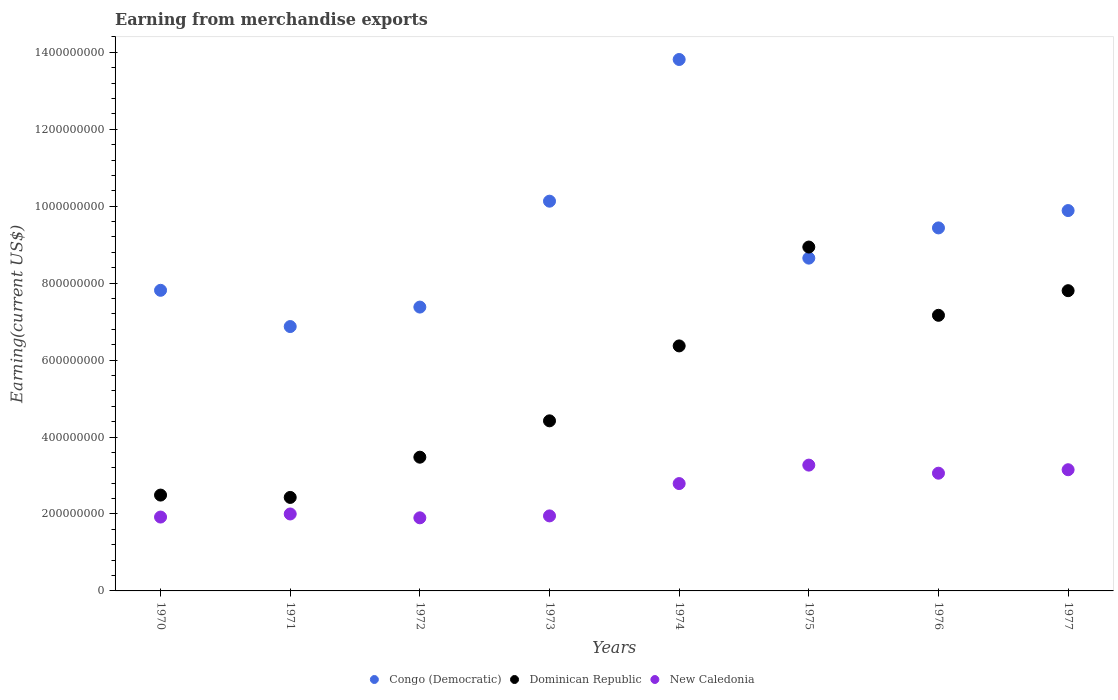Is the number of dotlines equal to the number of legend labels?
Provide a short and direct response. Yes. What is the amount earned from merchandise exports in Dominican Republic in 1977?
Your response must be concise. 7.80e+08. Across all years, what is the maximum amount earned from merchandise exports in New Caledonia?
Keep it short and to the point. 3.27e+08. Across all years, what is the minimum amount earned from merchandise exports in Congo (Democratic)?
Your answer should be compact. 6.87e+08. In which year was the amount earned from merchandise exports in Dominican Republic maximum?
Your response must be concise. 1975. What is the total amount earned from merchandise exports in New Caledonia in the graph?
Make the answer very short. 2.00e+09. What is the difference between the amount earned from merchandise exports in New Caledonia in 1973 and that in 1975?
Offer a terse response. -1.32e+08. What is the difference between the amount earned from merchandise exports in Congo (Democratic) in 1975 and the amount earned from merchandise exports in Dominican Republic in 1970?
Make the answer very short. 6.16e+08. What is the average amount earned from merchandise exports in Dominican Republic per year?
Keep it short and to the point. 5.39e+08. In the year 1972, what is the difference between the amount earned from merchandise exports in New Caledonia and amount earned from merchandise exports in Dominican Republic?
Provide a short and direct response. -1.58e+08. What is the ratio of the amount earned from merchandise exports in New Caledonia in 1971 to that in 1972?
Ensure brevity in your answer.  1.05. Is the amount earned from merchandise exports in New Caledonia in 1972 less than that in 1974?
Make the answer very short. Yes. Is the difference between the amount earned from merchandise exports in New Caledonia in 1970 and 1973 greater than the difference between the amount earned from merchandise exports in Dominican Republic in 1970 and 1973?
Keep it short and to the point. Yes. What is the difference between the highest and the second highest amount earned from merchandise exports in New Caledonia?
Offer a terse response. 1.20e+07. What is the difference between the highest and the lowest amount earned from merchandise exports in Congo (Democratic)?
Provide a succinct answer. 6.94e+08. Does the amount earned from merchandise exports in Dominican Republic monotonically increase over the years?
Your answer should be very brief. No. Is the amount earned from merchandise exports in Congo (Democratic) strictly greater than the amount earned from merchandise exports in Dominican Republic over the years?
Offer a terse response. No. Is the amount earned from merchandise exports in Dominican Republic strictly less than the amount earned from merchandise exports in Congo (Democratic) over the years?
Offer a terse response. No. How many years are there in the graph?
Make the answer very short. 8. Are the values on the major ticks of Y-axis written in scientific E-notation?
Your answer should be compact. No. Does the graph contain any zero values?
Provide a succinct answer. No. Where does the legend appear in the graph?
Your answer should be very brief. Bottom center. How are the legend labels stacked?
Make the answer very short. Horizontal. What is the title of the graph?
Ensure brevity in your answer.  Earning from merchandise exports. What is the label or title of the X-axis?
Your response must be concise. Years. What is the label or title of the Y-axis?
Provide a short and direct response. Earning(current US$). What is the Earning(current US$) of Congo (Democratic) in 1970?
Your response must be concise. 7.81e+08. What is the Earning(current US$) of Dominican Republic in 1970?
Keep it short and to the point. 2.49e+08. What is the Earning(current US$) of New Caledonia in 1970?
Your response must be concise. 1.92e+08. What is the Earning(current US$) of Congo (Democratic) in 1971?
Provide a succinct answer. 6.87e+08. What is the Earning(current US$) in Dominican Republic in 1971?
Your answer should be very brief. 2.43e+08. What is the Earning(current US$) in New Caledonia in 1971?
Provide a short and direct response. 2.00e+08. What is the Earning(current US$) of Congo (Democratic) in 1972?
Ensure brevity in your answer.  7.38e+08. What is the Earning(current US$) in Dominican Republic in 1972?
Provide a short and direct response. 3.48e+08. What is the Earning(current US$) of New Caledonia in 1972?
Offer a very short reply. 1.90e+08. What is the Earning(current US$) of Congo (Democratic) in 1973?
Give a very brief answer. 1.01e+09. What is the Earning(current US$) of Dominican Republic in 1973?
Your response must be concise. 4.42e+08. What is the Earning(current US$) of New Caledonia in 1973?
Ensure brevity in your answer.  1.95e+08. What is the Earning(current US$) of Congo (Democratic) in 1974?
Keep it short and to the point. 1.38e+09. What is the Earning(current US$) of Dominican Republic in 1974?
Ensure brevity in your answer.  6.37e+08. What is the Earning(current US$) in New Caledonia in 1974?
Make the answer very short. 2.79e+08. What is the Earning(current US$) in Congo (Democratic) in 1975?
Provide a short and direct response. 8.65e+08. What is the Earning(current US$) of Dominican Republic in 1975?
Offer a very short reply. 8.94e+08. What is the Earning(current US$) of New Caledonia in 1975?
Make the answer very short. 3.27e+08. What is the Earning(current US$) in Congo (Democratic) in 1976?
Provide a succinct answer. 9.44e+08. What is the Earning(current US$) in Dominican Republic in 1976?
Your answer should be very brief. 7.16e+08. What is the Earning(current US$) in New Caledonia in 1976?
Give a very brief answer. 3.06e+08. What is the Earning(current US$) of Congo (Democratic) in 1977?
Your answer should be very brief. 9.89e+08. What is the Earning(current US$) of Dominican Republic in 1977?
Provide a succinct answer. 7.80e+08. What is the Earning(current US$) in New Caledonia in 1977?
Make the answer very short. 3.15e+08. Across all years, what is the maximum Earning(current US$) in Congo (Democratic)?
Your answer should be very brief. 1.38e+09. Across all years, what is the maximum Earning(current US$) of Dominican Republic?
Offer a very short reply. 8.94e+08. Across all years, what is the maximum Earning(current US$) in New Caledonia?
Offer a very short reply. 3.27e+08. Across all years, what is the minimum Earning(current US$) of Congo (Democratic)?
Your answer should be compact. 6.87e+08. Across all years, what is the minimum Earning(current US$) of Dominican Republic?
Make the answer very short. 2.43e+08. Across all years, what is the minimum Earning(current US$) of New Caledonia?
Ensure brevity in your answer.  1.90e+08. What is the total Earning(current US$) in Congo (Democratic) in the graph?
Provide a succinct answer. 7.40e+09. What is the total Earning(current US$) of Dominican Republic in the graph?
Keep it short and to the point. 4.31e+09. What is the total Earning(current US$) in New Caledonia in the graph?
Give a very brief answer. 2.00e+09. What is the difference between the Earning(current US$) of Congo (Democratic) in 1970 and that in 1971?
Your answer should be compact. 9.42e+07. What is the difference between the Earning(current US$) of Dominican Republic in 1970 and that in 1971?
Offer a terse response. 6.07e+06. What is the difference between the Earning(current US$) in New Caledonia in 1970 and that in 1971?
Your answer should be very brief. -8.00e+06. What is the difference between the Earning(current US$) of Congo (Democratic) in 1970 and that in 1972?
Provide a succinct answer. 4.36e+07. What is the difference between the Earning(current US$) of Dominican Republic in 1970 and that in 1972?
Offer a very short reply. -9.85e+07. What is the difference between the Earning(current US$) of Congo (Democratic) in 1970 and that in 1973?
Your answer should be very brief. -2.32e+08. What is the difference between the Earning(current US$) in Dominican Republic in 1970 and that in 1973?
Your answer should be compact. -1.93e+08. What is the difference between the Earning(current US$) of New Caledonia in 1970 and that in 1973?
Ensure brevity in your answer.  -3.00e+06. What is the difference between the Earning(current US$) in Congo (Democratic) in 1970 and that in 1974?
Make the answer very short. -6.00e+08. What is the difference between the Earning(current US$) in Dominican Republic in 1970 and that in 1974?
Offer a terse response. -3.88e+08. What is the difference between the Earning(current US$) in New Caledonia in 1970 and that in 1974?
Your answer should be very brief. -8.70e+07. What is the difference between the Earning(current US$) of Congo (Democratic) in 1970 and that in 1975?
Give a very brief answer. -8.36e+07. What is the difference between the Earning(current US$) of Dominican Republic in 1970 and that in 1975?
Offer a terse response. -6.45e+08. What is the difference between the Earning(current US$) in New Caledonia in 1970 and that in 1975?
Give a very brief answer. -1.35e+08. What is the difference between the Earning(current US$) of Congo (Democratic) in 1970 and that in 1976?
Your response must be concise. -1.62e+08. What is the difference between the Earning(current US$) of Dominican Republic in 1970 and that in 1976?
Keep it short and to the point. -4.67e+08. What is the difference between the Earning(current US$) of New Caledonia in 1970 and that in 1976?
Your answer should be very brief. -1.14e+08. What is the difference between the Earning(current US$) in Congo (Democratic) in 1970 and that in 1977?
Give a very brief answer. -2.07e+08. What is the difference between the Earning(current US$) in Dominican Republic in 1970 and that in 1977?
Make the answer very short. -5.31e+08. What is the difference between the Earning(current US$) in New Caledonia in 1970 and that in 1977?
Keep it short and to the point. -1.23e+08. What is the difference between the Earning(current US$) in Congo (Democratic) in 1971 and that in 1972?
Your response must be concise. -5.06e+07. What is the difference between the Earning(current US$) of Dominican Republic in 1971 and that in 1972?
Give a very brief answer. -1.05e+08. What is the difference between the Earning(current US$) of New Caledonia in 1971 and that in 1972?
Ensure brevity in your answer.  1.00e+07. What is the difference between the Earning(current US$) in Congo (Democratic) in 1971 and that in 1973?
Your response must be concise. -3.26e+08. What is the difference between the Earning(current US$) in Dominican Republic in 1971 and that in 1973?
Your response must be concise. -1.99e+08. What is the difference between the Earning(current US$) of New Caledonia in 1971 and that in 1973?
Your answer should be very brief. 5.00e+06. What is the difference between the Earning(current US$) of Congo (Democratic) in 1971 and that in 1974?
Keep it short and to the point. -6.94e+08. What is the difference between the Earning(current US$) in Dominican Republic in 1971 and that in 1974?
Ensure brevity in your answer.  -3.94e+08. What is the difference between the Earning(current US$) of New Caledonia in 1971 and that in 1974?
Your answer should be compact. -7.90e+07. What is the difference between the Earning(current US$) in Congo (Democratic) in 1971 and that in 1975?
Give a very brief answer. -1.78e+08. What is the difference between the Earning(current US$) of Dominican Republic in 1971 and that in 1975?
Offer a terse response. -6.51e+08. What is the difference between the Earning(current US$) in New Caledonia in 1971 and that in 1975?
Offer a very short reply. -1.27e+08. What is the difference between the Earning(current US$) of Congo (Democratic) in 1971 and that in 1976?
Your answer should be compact. -2.56e+08. What is the difference between the Earning(current US$) in Dominican Republic in 1971 and that in 1976?
Your answer should be compact. -4.73e+08. What is the difference between the Earning(current US$) in New Caledonia in 1971 and that in 1976?
Your answer should be very brief. -1.06e+08. What is the difference between the Earning(current US$) in Congo (Democratic) in 1971 and that in 1977?
Offer a terse response. -3.01e+08. What is the difference between the Earning(current US$) in Dominican Republic in 1971 and that in 1977?
Make the answer very short. -5.37e+08. What is the difference between the Earning(current US$) in New Caledonia in 1971 and that in 1977?
Your response must be concise. -1.15e+08. What is the difference between the Earning(current US$) in Congo (Democratic) in 1972 and that in 1973?
Keep it short and to the point. -2.75e+08. What is the difference between the Earning(current US$) of Dominican Republic in 1972 and that in 1973?
Your answer should be very brief. -9.45e+07. What is the difference between the Earning(current US$) of New Caledonia in 1972 and that in 1973?
Keep it short and to the point. -5.00e+06. What is the difference between the Earning(current US$) in Congo (Democratic) in 1972 and that in 1974?
Offer a terse response. -6.44e+08. What is the difference between the Earning(current US$) in Dominican Republic in 1972 and that in 1974?
Provide a short and direct response. -2.89e+08. What is the difference between the Earning(current US$) of New Caledonia in 1972 and that in 1974?
Your response must be concise. -8.90e+07. What is the difference between the Earning(current US$) in Congo (Democratic) in 1972 and that in 1975?
Keep it short and to the point. -1.27e+08. What is the difference between the Earning(current US$) in Dominican Republic in 1972 and that in 1975?
Give a very brief answer. -5.46e+08. What is the difference between the Earning(current US$) in New Caledonia in 1972 and that in 1975?
Keep it short and to the point. -1.37e+08. What is the difference between the Earning(current US$) in Congo (Democratic) in 1972 and that in 1976?
Provide a succinct answer. -2.06e+08. What is the difference between the Earning(current US$) of Dominican Republic in 1972 and that in 1976?
Offer a very short reply. -3.69e+08. What is the difference between the Earning(current US$) of New Caledonia in 1972 and that in 1976?
Offer a terse response. -1.16e+08. What is the difference between the Earning(current US$) of Congo (Democratic) in 1972 and that in 1977?
Keep it short and to the point. -2.51e+08. What is the difference between the Earning(current US$) of Dominican Republic in 1972 and that in 1977?
Your answer should be compact. -4.33e+08. What is the difference between the Earning(current US$) of New Caledonia in 1972 and that in 1977?
Make the answer very short. -1.25e+08. What is the difference between the Earning(current US$) of Congo (Democratic) in 1973 and that in 1974?
Ensure brevity in your answer.  -3.68e+08. What is the difference between the Earning(current US$) of Dominican Republic in 1973 and that in 1974?
Offer a terse response. -1.95e+08. What is the difference between the Earning(current US$) in New Caledonia in 1973 and that in 1974?
Give a very brief answer. -8.40e+07. What is the difference between the Earning(current US$) of Congo (Democratic) in 1973 and that in 1975?
Your answer should be very brief. 1.48e+08. What is the difference between the Earning(current US$) in Dominican Republic in 1973 and that in 1975?
Provide a short and direct response. -4.52e+08. What is the difference between the Earning(current US$) in New Caledonia in 1973 and that in 1975?
Provide a succinct answer. -1.32e+08. What is the difference between the Earning(current US$) of Congo (Democratic) in 1973 and that in 1976?
Your answer should be very brief. 6.95e+07. What is the difference between the Earning(current US$) of Dominican Republic in 1973 and that in 1976?
Make the answer very short. -2.74e+08. What is the difference between the Earning(current US$) of New Caledonia in 1973 and that in 1976?
Ensure brevity in your answer.  -1.11e+08. What is the difference between the Earning(current US$) in Congo (Democratic) in 1973 and that in 1977?
Keep it short and to the point. 2.44e+07. What is the difference between the Earning(current US$) in Dominican Republic in 1973 and that in 1977?
Provide a succinct answer. -3.38e+08. What is the difference between the Earning(current US$) in New Caledonia in 1973 and that in 1977?
Offer a terse response. -1.20e+08. What is the difference between the Earning(current US$) of Congo (Democratic) in 1974 and that in 1975?
Provide a succinct answer. 5.16e+08. What is the difference between the Earning(current US$) of Dominican Republic in 1974 and that in 1975?
Make the answer very short. -2.57e+08. What is the difference between the Earning(current US$) in New Caledonia in 1974 and that in 1975?
Your answer should be very brief. -4.80e+07. What is the difference between the Earning(current US$) in Congo (Democratic) in 1974 and that in 1976?
Offer a very short reply. 4.38e+08. What is the difference between the Earning(current US$) in Dominican Republic in 1974 and that in 1976?
Give a very brief answer. -7.95e+07. What is the difference between the Earning(current US$) of New Caledonia in 1974 and that in 1976?
Your answer should be compact. -2.70e+07. What is the difference between the Earning(current US$) in Congo (Democratic) in 1974 and that in 1977?
Provide a succinct answer. 3.93e+08. What is the difference between the Earning(current US$) of Dominican Republic in 1974 and that in 1977?
Offer a very short reply. -1.44e+08. What is the difference between the Earning(current US$) of New Caledonia in 1974 and that in 1977?
Keep it short and to the point. -3.60e+07. What is the difference between the Earning(current US$) in Congo (Democratic) in 1975 and that in 1976?
Your answer should be compact. -7.86e+07. What is the difference between the Earning(current US$) in Dominican Republic in 1975 and that in 1976?
Provide a succinct answer. 1.77e+08. What is the difference between the Earning(current US$) in New Caledonia in 1975 and that in 1976?
Offer a terse response. 2.10e+07. What is the difference between the Earning(current US$) of Congo (Democratic) in 1975 and that in 1977?
Ensure brevity in your answer.  -1.24e+08. What is the difference between the Earning(current US$) of Dominican Republic in 1975 and that in 1977?
Make the answer very short. 1.13e+08. What is the difference between the Earning(current US$) of Congo (Democratic) in 1976 and that in 1977?
Your response must be concise. -4.51e+07. What is the difference between the Earning(current US$) of Dominican Republic in 1976 and that in 1977?
Provide a short and direct response. -6.40e+07. What is the difference between the Earning(current US$) of New Caledonia in 1976 and that in 1977?
Provide a short and direct response. -9.00e+06. What is the difference between the Earning(current US$) of Congo (Democratic) in 1970 and the Earning(current US$) of Dominican Republic in 1971?
Offer a very short reply. 5.38e+08. What is the difference between the Earning(current US$) of Congo (Democratic) in 1970 and the Earning(current US$) of New Caledonia in 1971?
Offer a very short reply. 5.81e+08. What is the difference between the Earning(current US$) in Dominican Republic in 1970 and the Earning(current US$) in New Caledonia in 1971?
Make the answer very short. 4.91e+07. What is the difference between the Earning(current US$) of Congo (Democratic) in 1970 and the Earning(current US$) of Dominican Republic in 1972?
Give a very brief answer. 4.34e+08. What is the difference between the Earning(current US$) in Congo (Democratic) in 1970 and the Earning(current US$) in New Caledonia in 1972?
Provide a succinct answer. 5.91e+08. What is the difference between the Earning(current US$) of Dominican Republic in 1970 and the Earning(current US$) of New Caledonia in 1972?
Give a very brief answer. 5.91e+07. What is the difference between the Earning(current US$) of Congo (Democratic) in 1970 and the Earning(current US$) of Dominican Republic in 1973?
Provide a short and direct response. 3.39e+08. What is the difference between the Earning(current US$) of Congo (Democratic) in 1970 and the Earning(current US$) of New Caledonia in 1973?
Make the answer very short. 5.86e+08. What is the difference between the Earning(current US$) in Dominican Republic in 1970 and the Earning(current US$) in New Caledonia in 1973?
Keep it short and to the point. 5.41e+07. What is the difference between the Earning(current US$) in Congo (Democratic) in 1970 and the Earning(current US$) in Dominican Republic in 1974?
Make the answer very short. 1.45e+08. What is the difference between the Earning(current US$) in Congo (Democratic) in 1970 and the Earning(current US$) in New Caledonia in 1974?
Offer a very short reply. 5.02e+08. What is the difference between the Earning(current US$) of Dominican Republic in 1970 and the Earning(current US$) of New Caledonia in 1974?
Give a very brief answer. -2.99e+07. What is the difference between the Earning(current US$) in Congo (Democratic) in 1970 and the Earning(current US$) in Dominican Republic in 1975?
Ensure brevity in your answer.  -1.12e+08. What is the difference between the Earning(current US$) of Congo (Democratic) in 1970 and the Earning(current US$) of New Caledonia in 1975?
Your response must be concise. 4.54e+08. What is the difference between the Earning(current US$) of Dominican Republic in 1970 and the Earning(current US$) of New Caledonia in 1975?
Make the answer very short. -7.79e+07. What is the difference between the Earning(current US$) of Congo (Democratic) in 1970 and the Earning(current US$) of Dominican Republic in 1976?
Your answer should be compact. 6.50e+07. What is the difference between the Earning(current US$) of Congo (Democratic) in 1970 and the Earning(current US$) of New Caledonia in 1976?
Ensure brevity in your answer.  4.75e+08. What is the difference between the Earning(current US$) of Dominican Republic in 1970 and the Earning(current US$) of New Caledonia in 1976?
Your answer should be very brief. -5.69e+07. What is the difference between the Earning(current US$) in Congo (Democratic) in 1970 and the Earning(current US$) in Dominican Republic in 1977?
Provide a succinct answer. 9.97e+05. What is the difference between the Earning(current US$) in Congo (Democratic) in 1970 and the Earning(current US$) in New Caledonia in 1977?
Your answer should be very brief. 4.66e+08. What is the difference between the Earning(current US$) in Dominican Republic in 1970 and the Earning(current US$) in New Caledonia in 1977?
Provide a short and direct response. -6.59e+07. What is the difference between the Earning(current US$) in Congo (Democratic) in 1971 and the Earning(current US$) in Dominican Republic in 1972?
Make the answer very short. 3.40e+08. What is the difference between the Earning(current US$) in Congo (Democratic) in 1971 and the Earning(current US$) in New Caledonia in 1972?
Offer a terse response. 4.97e+08. What is the difference between the Earning(current US$) of Dominican Republic in 1971 and the Earning(current US$) of New Caledonia in 1972?
Ensure brevity in your answer.  5.30e+07. What is the difference between the Earning(current US$) in Congo (Democratic) in 1971 and the Earning(current US$) in Dominican Republic in 1973?
Ensure brevity in your answer.  2.45e+08. What is the difference between the Earning(current US$) of Congo (Democratic) in 1971 and the Earning(current US$) of New Caledonia in 1973?
Make the answer very short. 4.92e+08. What is the difference between the Earning(current US$) of Dominican Republic in 1971 and the Earning(current US$) of New Caledonia in 1973?
Keep it short and to the point. 4.80e+07. What is the difference between the Earning(current US$) of Congo (Democratic) in 1971 and the Earning(current US$) of Dominican Republic in 1974?
Offer a very short reply. 5.03e+07. What is the difference between the Earning(current US$) of Congo (Democratic) in 1971 and the Earning(current US$) of New Caledonia in 1974?
Provide a succinct answer. 4.08e+08. What is the difference between the Earning(current US$) of Dominican Republic in 1971 and the Earning(current US$) of New Caledonia in 1974?
Your response must be concise. -3.60e+07. What is the difference between the Earning(current US$) of Congo (Democratic) in 1971 and the Earning(current US$) of Dominican Republic in 1975?
Provide a succinct answer. -2.07e+08. What is the difference between the Earning(current US$) in Congo (Democratic) in 1971 and the Earning(current US$) in New Caledonia in 1975?
Your answer should be compact. 3.60e+08. What is the difference between the Earning(current US$) in Dominican Republic in 1971 and the Earning(current US$) in New Caledonia in 1975?
Provide a succinct answer. -8.40e+07. What is the difference between the Earning(current US$) in Congo (Democratic) in 1971 and the Earning(current US$) in Dominican Republic in 1976?
Make the answer very short. -2.92e+07. What is the difference between the Earning(current US$) in Congo (Democratic) in 1971 and the Earning(current US$) in New Caledonia in 1976?
Ensure brevity in your answer.  3.81e+08. What is the difference between the Earning(current US$) of Dominican Republic in 1971 and the Earning(current US$) of New Caledonia in 1976?
Your answer should be compact. -6.30e+07. What is the difference between the Earning(current US$) of Congo (Democratic) in 1971 and the Earning(current US$) of Dominican Republic in 1977?
Make the answer very short. -9.32e+07. What is the difference between the Earning(current US$) in Congo (Democratic) in 1971 and the Earning(current US$) in New Caledonia in 1977?
Make the answer very short. 3.72e+08. What is the difference between the Earning(current US$) in Dominican Republic in 1971 and the Earning(current US$) in New Caledonia in 1977?
Ensure brevity in your answer.  -7.20e+07. What is the difference between the Earning(current US$) of Congo (Democratic) in 1972 and the Earning(current US$) of Dominican Republic in 1973?
Your answer should be compact. 2.96e+08. What is the difference between the Earning(current US$) of Congo (Democratic) in 1972 and the Earning(current US$) of New Caledonia in 1973?
Provide a short and direct response. 5.43e+08. What is the difference between the Earning(current US$) of Dominican Republic in 1972 and the Earning(current US$) of New Caledonia in 1973?
Make the answer very short. 1.53e+08. What is the difference between the Earning(current US$) in Congo (Democratic) in 1972 and the Earning(current US$) in Dominican Republic in 1974?
Your answer should be very brief. 1.01e+08. What is the difference between the Earning(current US$) in Congo (Democratic) in 1972 and the Earning(current US$) in New Caledonia in 1974?
Provide a short and direct response. 4.59e+08. What is the difference between the Earning(current US$) in Dominican Republic in 1972 and the Earning(current US$) in New Caledonia in 1974?
Keep it short and to the point. 6.86e+07. What is the difference between the Earning(current US$) of Congo (Democratic) in 1972 and the Earning(current US$) of Dominican Republic in 1975?
Your response must be concise. -1.56e+08. What is the difference between the Earning(current US$) of Congo (Democratic) in 1972 and the Earning(current US$) of New Caledonia in 1975?
Offer a terse response. 4.11e+08. What is the difference between the Earning(current US$) of Dominican Republic in 1972 and the Earning(current US$) of New Caledonia in 1975?
Keep it short and to the point. 2.06e+07. What is the difference between the Earning(current US$) of Congo (Democratic) in 1972 and the Earning(current US$) of Dominican Republic in 1976?
Your answer should be compact. 2.14e+07. What is the difference between the Earning(current US$) in Congo (Democratic) in 1972 and the Earning(current US$) in New Caledonia in 1976?
Your response must be concise. 4.32e+08. What is the difference between the Earning(current US$) of Dominican Republic in 1972 and the Earning(current US$) of New Caledonia in 1976?
Offer a terse response. 4.16e+07. What is the difference between the Earning(current US$) of Congo (Democratic) in 1972 and the Earning(current US$) of Dominican Republic in 1977?
Provide a short and direct response. -4.26e+07. What is the difference between the Earning(current US$) in Congo (Democratic) in 1972 and the Earning(current US$) in New Caledonia in 1977?
Make the answer very short. 4.23e+08. What is the difference between the Earning(current US$) in Dominican Republic in 1972 and the Earning(current US$) in New Caledonia in 1977?
Your answer should be very brief. 3.26e+07. What is the difference between the Earning(current US$) in Congo (Democratic) in 1973 and the Earning(current US$) in Dominican Republic in 1974?
Offer a terse response. 3.76e+08. What is the difference between the Earning(current US$) in Congo (Democratic) in 1973 and the Earning(current US$) in New Caledonia in 1974?
Keep it short and to the point. 7.34e+08. What is the difference between the Earning(current US$) in Dominican Republic in 1973 and the Earning(current US$) in New Caledonia in 1974?
Offer a very short reply. 1.63e+08. What is the difference between the Earning(current US$) in Congo (Democratic) in 1973 and the Earning(current US$) in Dominican Republic in 1975?
Keep it short and to the point. 1.19e+08. What is the difference between the Earning(current US$) in Congo (Democratic) in 1973 and the Earning(current US$) in New Caledonia in 1975?
Give a very brief answer. 6.86e+08. What is the difference between the Earning(current US$) of Dominican Republic in 1973 and the Earning(current US$) of New Caledonia in 1975?
Make the answer very short. 1.15e+08. What is the difference between the Earning(current US$) of Congo (Democratic) in 1973 and the Earning(current US$) of Dominican Republic in 1976?
Make the answer very short. 2.97e+08. What is the difference between the Earning(current US$) in Congo (Democratic) in 1973 and the Earning(current US$) in New Caledonia in 1976?
Keep it short and to the point. 7.07e+08. What is the difference between the Earning(current US$) of Dominican Republic in 1973 and the Earning(current US$) of New Caledonia in 1976?
Ensure brevity in your answer.  1.36e+08. What is the difference between the Earning(current US$) in Congo (Democratic) in 1973 and the Earning(current US$) in Dominican Republic in 1977?
Keep it short and to the point. 2.33e+08. What is the difference between the Earning(current US$) in Congo (Democratic) in 1973 and the Earning(current US$) in New Caledonia in 1977?
Give a very brief answer. 6.98e+08. What is the difference between the Earning(current US$) of Dominican Republic in 1973 and the Earning(current US$) of New Caledonia in 1977?
Make the answer very short. 1.27e+08. What is the difference between the Earning(current US$) in Congo (Democratic) in 1974 and the Earning(current US$) in Dominican Republic in 1975?
Your answer should be compact. 4.87e+08. What is the difference between the Earning(current US$) in Congo (Democratic) in 1974 and the Earning(current US$) in New Caledonia in 1975?
Make the answer very short. 1.05e+09. What is the difference between the Earning(current US$) of Dominican Republic in 1974 and the Earning(current US$) of New Caledonia in 1975?
Keep it short and to the point. 3.10e+08. What is the difference between the Earning(current US$) in Congo (Democratic) in 1974 and the Earning(current US$) in Dominican Republic in 1976?
Ensure brevity in your answer.  6.65e+08. What is the difference between the Earning(current US$) of Congo (Democratic) in 1974 and the Earning(current US$) of New Caledonia in 1976?
Ensure brevity in your answer.  1.08e+09. What is the difference between the Earning(current US$) in Dominican Republic in 1974 and the Earning(current US$) in New Caledonia in 1976?
Ensure brevity in your answer.  3.31e+08. What is the difference between the Earning(current US$) in Congo (Democratic) in 1974 and the Earning(current US$) in Dominican Republic in 1977?
Provide a succinct answer. 6.01e+08. What is the difference between the Earning(current US$) of Congo (Democratic) in 1974 and the Earning(current US$) of New Caledonia in 1977?
Provide a short and direct response. 1.07e+09. What is the difference between the Earning(current US$) of Dominican Republic in 1974 and the Earning(current US$) of New Caledonia in 1977?
Your answer should be very brief. 3.22e+08. What is the difference between the Earning(current US$) in Congo (Democratic) in 1975 and the Earning(current US$) in Dominican Republic in 1976?
Your answer should be compact. 1.49e+08. What is the difference between the Earning(current US$) of Congo (Democratic) in 1975 and the Earning(current US$) of New Caledonia in 1976?
Offer a very short reply. 5.59e+08. What is the difference between the Earning(current US$) in Dominican Republic in 1975 and the Earning(current US$) in New Caledonia in 1976?
Your response must be concise. 5.88e+08. What is the difference between the Earning(current US$) of Congo (Democratic) in 1975 and the Earning(current US$) of Dominican Republic in 1977?
Ensure brevity in your answer.  8.46e+07. What is the difference between the Earning(current US$) of Congo (Democratic) in 1975 and the Earning(current US$) of New Caledonia in 1977?
Give a very brief answer. 5.50e+08. What is the difference between the Earning(current US$) of Dominican Republic in 1975 and the Earning(current US$) of New Caledonia in 1977?
Offer a very short reply. 5.79e+08. What is the difference between the Earning(current US$) in Congo (Democratic) in 1976 and the Earning(current US$) in Dominican Republic in 1977?
Make the answer very short. 1.63e+08. What is the difference between the Earning(current US$) in Congo (Democratic) in 1976 and the Earning(current US$) in New Caledonia in 1977?
Give a very brief answer. 6.29e+08. What is the difference between the Earning(current US$) in Dominican Republic in 1976 and the Earning(current US$) in New Caledonia in 1977?
Give a very brief answer. 4.01e+08. What is the average Earning(current US$) in Congo (Democratic) per year?
Ensure brevity in your answer.  9.25e+08. What is the average Earning(current US$) in Dominican Republic per year?
Keep it short and to the point. 5.39e+08. What is the average Earning(current US$) in New Caledonia per year?
Offer a terse response. 2.50e+08. In the year 1970, what is the difference between the Earning(current US$) in Congo (Democratic) and Earning(current US$) in Dominican Republic?
Make the answer very short. 5.32e+08. In the year 1970, what is the difference between the Earning(current US$) of Congo (Democratic) and Earning(current US$) of New Caledonia?
Provide a short and direct response. 5.89e+08. In the year 1970, what is the difference between the Earning(current US$) in Dominican Republic and Earning(current US$) in New Caledonia?
Ensure brevity in your answer.  5.71e+07. In the year 1971, what is the difference between the Earning(current US$) in Congo (Democratic) and Earning(current US$) in Dominican Republic?
Provide a short and direct response. 4.44e+08. In the year 1971, what is the difference between the Earning(current US$) of Congo (Democratic) and Earning(current US$) of New Caledonia?
Your answer should be very brief. 4.87e+08. In the year 1971, what is the difference between the Earning(current US$) in Dominican Republic and Earning(current US$) in New Caledonia?
Your answer should be very brief. 4.30e+07. In the year 1972, what is the difference between the Earning(current US$) in Congo (Democratic) and Earning(current US$) in Dominican Republic?
Ensure brevity in your answer.  3.90e+08. In the year 1972, what is the difference between the Earning(current US$) of Congo (Democratic) and Earning(current US$) of New Caledonia?
Your answer should be very brief. 5.48e+08. In the year 1972, what is the difference between the Earning(current US$) of Dominican Republic and Earning(current US$) of New Caledonia?
Give a very brief answer. 1.58e+08. In the year 1973, what is the difference between the Earning(current US$) in Congo (Democratic) and Earning(current US$) in Dominican Republic?
Ensure brevity in your answer.  5.71e+08. In the year 1973, what is the difference between the Earning(current US$) of Congo (Democratic) and Earning(current US$) of New Caledonia?
Offer a terse response. 8.18e+08. In the year 1973, what is the difference between the Earning(current US$) of Dominican Republic and Earning(current US$) of New Caledonia?
Provide a short and direct response. 2.47e+08. In the year 1974, what is the difference between the Earning(current US$) in Congo (Democratic) and Earning(current US$) in Dominican Republic?
Provide a short and direct response. 7.44e+08. In the year 1974, what is the difference between the Earning(current US$) in Congo (Democratic) and Earning(current US$) in New Caledonia?
Provide a succinct answer. 1.10e+09. In the year 1974, what is the difference between the Earning(current US$) of Dominican Republic and Earning(current US$) of New Caledonia?
Offer a terse response. 3.58e+08. In the year 1975, what is the difference between the Earning(current US$) of Congo (Democratic) and Earning(current US$) of Dominican Republic?
Provide a succinct answer. -2.88e+07. In the year 1975, what is the difference between the Earning(current US$) in Congo (Democratic) and Earning(current US$) in New Caledonia?
Keep it short and to the point. 5.38e+08. In the year 1975, what is the difference between the Earning(current US$) of Dominican Republic and Earning(current US$) of New Caledonia?
Your answer should be very brief. 5.67e+08. In the year 1976, what is the difference between the Earning(current US$) in Congo (Democratic) and Earning(current US$) in Dominican Republic?
Provide a short and direct response. 2.27e+08. In the year 1976, what is the difference between the Earning(current US$) in Congo (Democratic) and Earning(current US$) in New Caledonia?
Provide a short and direct response. 6.38e+08. In the year 1976, what is the difference between the Earning(current US$) in Dominican Republic and Earning(current US$) in New Caledonia?
Your answer should be very brief. 4.10e+08. In the year 1977, what is the difference between the Earning(current US$) in Congo (Democratic) and Earning(current US$) in Dominican Republic?
Offer a terse response. 2.08e+08. In the year 1977, what is the difference between the Earning(current US$) of Congo (Democratic) and Earning(current US$) of New Caledonia?
Ensure brevity in your answer.  6.74e+08. In the year 1977, what is the difference between the Earning(current US$) in Dominican Republic and Earning(current US$) in New Caledonia?
Provide a succinct answer. 4.65e+08. What is the ratio of the Earning(current US$) of Congo (Democratic) in 1970 to that in 1971?
Give a very brief answer. 1.14. What is the ratio of the Earning(current US$) in Dominican Republic in 1970 to that in 1971?
Give a very brief answer. 1.02. What is the ratio of the Earning(current US$) in Congo (Democratic) in 1970 to that in 1972?
Your answer should be very brief. 1.06. What is the ratio of the Earning(current US$) of Dominican Republic in 1970 to that in 1972?
Offer a very short reply. 0.72. What is the ratio of the Earning(current US$) in New Caledonia in 1970 to that in 1972?
Ensure brevity in your answer.  1.01. What is the ratio of the Earning(current US$) of Congo (Democratic) in 1970 to that in 1973?
Provide a succinct answer. 0.77. What is the ratio of the Earning(current US$) of Dominican Republic in 1970 to that in 1973?
Offer a very short reply. 0.56. What is the ratio of the Earning(current US$) in New Caledonia in 1970 to that in 1973?
Make the answer very short. 0.98. What is the ratio of the Earning(current US$) in Congo (Democratic) in 1970 to that in 1974?
Give a very brief answer. 0.57. What is the ratio of the Earning(current US$) of Dominican Republic in 1970 to that in 1974?
Give a very brief answer. 0.39. What is the ratio of the Earning(current US$) of New Caledonia in 1970 to that in 1974?
Keep it short and to the point. 0.69. What is the ratio of the Earning(current US$) of Congo (Democratic) in 1970 to that in 1975?
Give a very brief answer. 0.9. What is the ratio of the Earning(current US$) of Dominican Republic in 1970 to that in 1975?
Your response must be concise. 0.28. What is the ratio of the Earning(current US$) in New Caledonia in 1970 to that in 1975?
Ensure brevity in your answer.  0.59. What is the ratio of the Earning(current US$) of Congo (Democratic) in 1970 to that in 1976?
Offer a terse response. 0.83. What is the ratio of the Earning(current US$) of Dominican Republic in 1970 to that in 1976?
Your answer should be very brief. 0.35. What is the ratio of the Earning(current US$) of New Caledonia in 1970 to that in 1976?
Your response must be concise. 0.63. What is the ratio of the Earning(current US$) of Congo (Democratic) in 1970 to that in 1977?
Your response must be concise. 0.79. What is the ratio of the Earning(current US$) in Dominican Republic in 1970 to that in 1977?
Provide a succinct answer. 0.32. What is the ratio of the Earning(current US$) of New Caledonia in 1970 to that in 1977?
Offer a terse response. 0.61. What is the ratio of the Earning(current US$) in Congo (Democratic) in 1971 to that in 1972?
Offer a very short reply. 0.93. What is the ratio of the Earning(current US$) in Dominican Republic in 1971 to that in 1972?
Your response must be concise. 0.7. What is the ratio of the Earning(current US$) in New Caledonia in 1971 to that in 1972?
Your answer should be very brief. 1.05. What is the ratio of the Earning(current US$) of Congo (Democratic) in 1971 to that in 1973?
Give a very brief answer. 0.68. What is the ratio of the Earning(current US$) of Dominican Republic in 1971 to that in 1973?
Your answer should be very brief. 0.55. What is the ratio of the Earning(current US$) of New Caledonia in 1971 to that in 1973?
Keep it short and to the point. 1.03. What is the ratio of the Earning(current US$) of Congo (Democratic) in 1971 to that in 1974?
Offer a very short reply. 0.5. What is the ratio of the Earning(current US$) of Dominican Republic in 1971 to that in 1974?
Make the answer very short. 0.38. What is the ratio of the Earning(current US$) of New Caledonia in 1971 to that in 1974?
Your answer should be compact. 0.72. What is the ratio of the Earning(current US$) in Congo (Democratic) in 1971 to that in 1975?
Ensure brevity in your answer.  0.79. What is the ratio of the Earning(current US$) in Dominican Republic in 1971 to that in 1975?
Offer a very short reply. 0.27. What is the ratio of the Earning(current US$) in New Caledonia in 1971 to that in 1975?
Keep it short and to the point. 0.61. What is the ratio of the Earning(current US$) in Congo (Democratic) in 1971 to that in 1976?
Keep it short and to the point. 0.73. What is the ratio of the Earning(current US$) in Dominican Republic in 1971 to that in 1976?
Keep it short and to the point. 0.34. What is the ratio of the Earning(current US$) of New Caledonia in 1971 to that in 1976?
Your answer should be very brief. 0.65. What is the ratio of the Earning(current US$) of Congo (Democratic) in 1971 to that in 1977?
Provide a short and direct response. 0.7. What is the ratio of the Earning(current US$) of Dominican Republic in 1971 to that in 1977?
Ensure brevity in your answer.  0.31. What is the ratio of the Earning(current US$) in New Caledonia in 1971 to that in 1977?
Give a very brief answer. 0.63. What is the ratio of the Earning(current US$) of Congo (Democratic) in 1972 to that in 1973?
Give a very brief answer. 0.73. What is the ratio of the Earning(current US$) in Dominican Republic in 1972 to that in 1973?
Provide a succinct answer. 0.79. What is the ratio of the Earning(current US$) of New Caledonia in 1972 to that in 1973?
Your response must be concise. 0.97. What is the ratio of the Earning(current US$) in Congo (Democratic) in 1972 to that in 1974?
Provide a short and direct response. 0.53. What is the ratio of the Earning(current US$) of Dominican Republic in 1972 to that in 1974?
Give a very brief answer. 0.55. What is the ratio of the Earning(current US$) of New Caledonia in 1972 to that in 1974?
Keep it short and to the point. 0.68. What is the ratio of the Earning(current US$) of Congo (Democratic) in 1972 to that in 1975?
Make the answer very short. 0.85. What is the ratio of the Earning(current US$) in Dominican Republic in 1972 to that in 1975?
Your answer should be compact. 0.39. What is the ratio of the Earning(current US$) in New Caledonia in 1972 to that in 1975?
Provide a succinct answer. 0.58. What is the ratio of the Earning(current US$) in Congo (Democratic) in 1972 to that in 1976?
Make the answer very short. 0.78. What is the ratio of the Earning(current US$) of Dominican Republic in 1972 to that in 1976?
Ensure brevity in your answer.  0.49. What is the ratio of the Earning(current US$) in New Caledonia in 1972 to that in 1976?
Offer a terse response. 0.62. What is the ratio of the Earning(current US$) of Congo (Democratic) in 1972 to that in 1977?
Your answer should be very brief. 0.75. What is the ratio of the Earning(current US$) in Dominican Republic in 1972 to that in 1977?
Give a very brief answer. 0.45. What is the ratio of the Earning(current US$) of New Caledonia in 1972 to that in 1977?
Offer a terse response. 0.6. What is the ratio of the Earning(current US$) of Congo (Democratic) in 1973 to that in 1974?
Offer a very short reply. 0.73. What is the ratio of the Earning(current US$) in Dominican Republic in 1973 to that in 1974?
Make the answer very short. 0.69. What is the ratio of the Earning(current US$) in New Caledonia in 1973 to that in 1974?
Your answer should be very brief. 0.7. What is the ratio of the Earning(current US$) in Congo (Democratic) in 1973 to that in 1975?
Your response must be concise. 1.17. What is the ratio of the Earning(current US$) of Dominican Republic in 1973 to that in 1975?
Provide a succinct answer. 0.49. What is the ratio of the Earning(current US$) of New Caledonia in 1973 to that in 1975?
Provide a succinct answer. 0.6. What is the ratio of the Earning(current US$) of Congo (Democratic) in 1973 to that in 1976?
Give a very brief answer. 1.07. What is the ratio of the Earning(current US$) of Dominican Republic in 1973 to that in 1976?
Provide a succinct answer. 0.62. What is the ratio of the Earning(current US$) in New Caledonia in 1973 to that in 1976?
Offer a terse response. 0.64. What is the ratio of the Earning(current US$) in Congo (Democratic) in 1973 to that in 1977?
Give a very brief answer. 1.02. What is the ratio of the Earning(current US$) of Dominican Republic in 1973 to that in 1977?
Provide a short and direct response. 0.57. What is the ratio of the Earning(current US$) in New Caledonia in 1973 to that in 1977?
Offer a very short reply. 0.62. What is the ratio of the Earning(current US$) of Congo (Democratic) in 1974 to that in 1975?
Provide a succinct answer. 1.6. What is the ratio of the Earning(current US$) in Dominican Republic in 1974 to that in 1975?
Offer a very short reply. 0.71. What is the ratio of the Earning(current US$) in New Caledonia in 1974 to that in 1975?
Ensure brevity in your answer.  0.85. What is the ratio of the Earning(current US$) of Congo (Democratic) in 1974 to that in 1976?
Provide a short and direct response. 1.46. What is the ratio of the Earning(current US$) of Dominican Republic in 1974 to that in 1976?
Keep it short and to the point. 0.89. What is the ratio of the Earning(current US$) of New Caledonia in 1974 to that in 1976?
Provide a short and direct response. 0.91. What is the ratio of the Earning(current US$) in Congo (Democratic) in 1974 to that in 1977?
Provide a short and direct response. 1.4. What is the ratio of the Earning(current US$) of Dominican Republic in 1974 to that in 1977?
Give a very brief answer. 0.82. What is the ratio of the Earning(current US$) in New Caledonia in 1974 to that in 1977?
Your response must be concise. 0.89. What is the ratio of the Earning(current US$) of Congo (Democratic) in 1975 to that in 1976?
Offer a very short reply. 0.92. What is the ratio of the Earning(current US$) of Dominican Republic in 1975 to that in 1976?
Your answer should be compact. 1.25. What is the ratio of the Earning(current US$) in New Caledonia in 1975 to that in 1976?
Provide a succinct answer. 1.07. What is the ratio of the Earning(current US$) in Congo (Democratic) in 1975 to that in 1977?
Ensure brevity in your answer.  0.87. What is the ratio of the Earning(current US$) in Dominican Republic in 1975 to that in 1977?
Provide a short and direct response. 1.15. What is the ratio of the Earning(current US$) in New Caledonia in 1975 to that in 1977?
Provide a short and direct response. 1.04. What is the ratio of the Earning(current US$) of Congo (Democratic) in 1976 to that in 1977?
Your answer should be very brief. 0.95. What is the ratio of the Earning(current US$) in Dominican Republic in 1976 to that in 1977?
Your answer should be very brief. 0.92. What is the ratio of the Earning(current US$) of New Caledonia in 1976 to that in 1977?
Offer a very short reply. 0.97. What is the difference between the highest and the second highest Earning(current US$) in Congo (Democratic)?
Offer a terse response. 3.68e+08. What is the difference between the highest and the second highest Earning(current US$) in Dominican Republic?
Give a very brief answer. 1.13e+08. What is the difference between the highest and the lowest Earning(current US$) of Congo (Democratic)?
Ensure brevity in your answer.  6.94e+08. What is the difference between the highest and the lowest Earning(current US$) of Dominican Republic?
Make the answer very short. 6.51e+08. What is the difference between the highest and the lowest Earning(current US$) of New Caledonia?
Offer a terse response. 1.37e+08. 